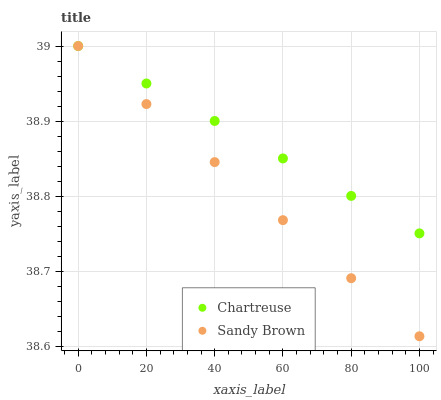Does Sandy Brown have the minimum area under the curve?
Answer yes or no. Yes. Does Chartreuse have the maximum area under the curve?
Answer yes or no. Yes. Does Sandy Brown have the maximum area under the curve?
Answer yes or no. No. Is Sandy Brown the smoothest?
Answer yes or no. Yes. Is Chartreuse the roughest?
Answer yes or no. Yes. Is Sandy Brown the roughest?
Answer yes or no. No. Does Sandy Brown have the lowest value?
Answer yes or no. Yes. Does Sandy Brown have the highest value?
Answer yes or no. Yes. Does Sandy Brown intersect Chartreuse?
Answer yes or no. Yes. Is Sandy Brown less than Chartreuse?
Answer yes or no. No. Is Sandy Brown greater than Chartreuse?
Answer yes or no. No. 